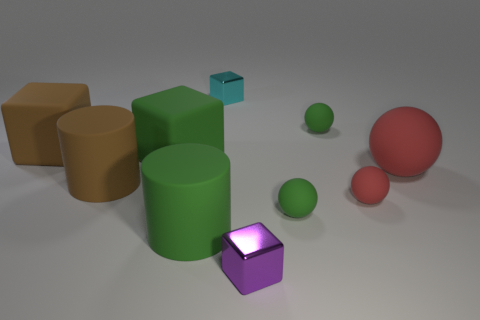Are there an equal number of tiny purple metal blocks left of the cyan thing and green objects that are on the right side of the large red thing?
Keep it short and to the point. Yes. Are there any other things that are the same material as the large brown cylinder?
Keep it short and to the point. Yes. The rubber cylinder that is to the right of the brown rubber cylinder is what color?
Keep it short and to the point. Green. Are there the same number of big green cylinders in front of the brown matte cylinder and green things?
Provide a short and direct response. No. What number of other things are the same shape as the big red object?
Provide a short and direct response. 3. There is a brown cylinder; how many big rubber balls are in front of it?
Keep it short and to the point. 0. How big is the green thing that is in front of the big red ball and left of the tiny cyan block?
Make the answer very short. Large. Is there a green rubber cube?
Your answer should be very brief. Yes. How many other things are there of the same size as the brown matte cube?
Your answer should be very brief. 4. Does the rubber object that is behind the brown matte cube have the same color as the tiny cube that is in front of the cyan metallic object?
Keep it short and to the point. No. 